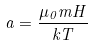<formula> <loc_0><loc_0><loc_500><loc_500>a = \frac { \mu _ { 0 } m H } { k T }</formula> 